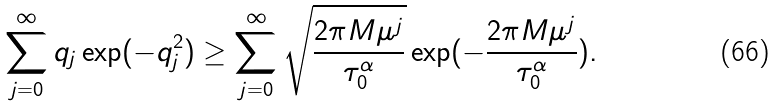<formula> <loc_0><loc_0><loc_500><loc_500>\sum _ { j = 0 } ^ { \infty } q _ { j } \exp ( - q _ { j } ^ { 2 } ) \geq \sum _ { j = 0 } ^ { \infty } \sqrt { \frac { 2 \pi M \mu ^ { j } } { \tau _ { 0 } ^ { \alpha } } } \exp ( - \frac { 2 \pi M \mu ^ { j } } { \tau _ { 0 } ^ { \alpha } } ) .</formula> 